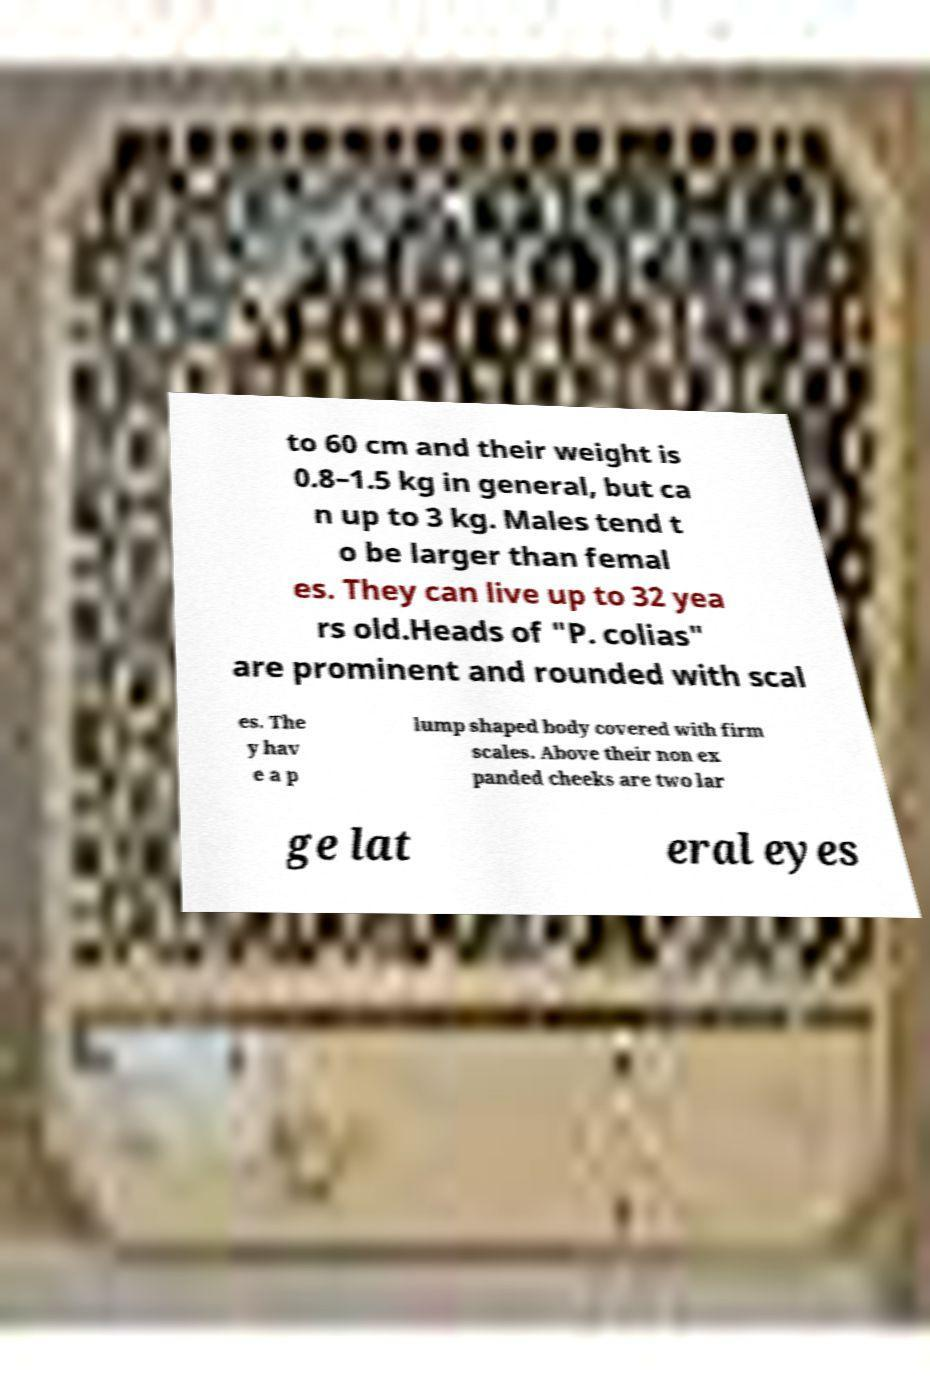Please read and relay the text visible in this image. What does it say? to 60 cm and their weight is 0.8–1.5 kg in general, but ca n up to 3 kg. Males tend t o be larger than femal es. They can live up to 32 yea rs old.Heads of "P. colias" are prominent and rounded with scal es. The y hav e a p lump shaped body covered with firm scales. Above their non ex panded cheeks are two lar ge lat eral eyes 